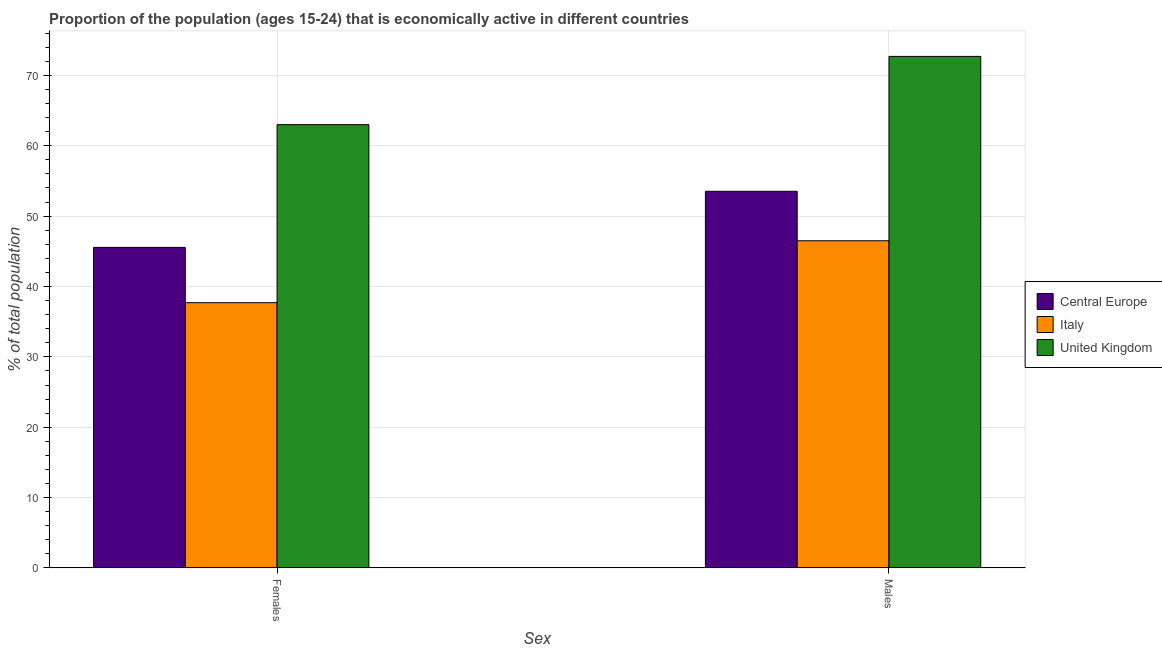How many different coloured bars are there?
Provide a short and direct response. 3. How many bars are there on the 2nd tick from the left?
Offer a terse response. 3. How many bars are there on the 2nd tick from the right?
Keep it short and to the point. 3. What is the label of the 1st group of bars from the left?
Make the answer very short. Females. What is the percentage of economically active female population in United Kingdom?
Ensure brevity in your answer.  63. Across all countries, what is the maximum percentage of economically active male population?
Make the answer very short. 72.7. Across all countries, what is the minimum percentage of economically active female population?
Offer a terse response. 37.7. What is the total percentage of economically active male population in the graph?
Ensure brevity in your answer.  172.73. What is the difference between the percentage of economically active female population in Italy and that in Central Europe?
Keep it short and to the point. -7.86. What is the difference between the percentage of economically active male population in Central Europe and the percentage of economically active female population in Italy?
Your answer should be compact. 15.83. What is the average percentage of economically active male population per country?
Offer a very short reply. 57.58. What is the difference between the percentage of economically active female population and percentage of economically active male population in United Kingdom?
Make the answer very short. -9.7. In how many countries, is the percentage of economically active male population greater than 74 %?
Your answer should be compact. 0. What is the ratio of the percentage of economically active female population in Italy to that in United Kingdom?
Make the answer very short. 0.6. Is the percentage of economically active female population in United Kingdom less than that in Italy?
Offer a very short reply. No. In how many countries, is the percentage of economically active female population greater than the average percentage of economically active female population taken over all countries?
Your response must be concise. 1. What does the 1st bar from the left in Males represents?
Your answer should be very brief. Central Europe. What does the 3rd bar from the right in Males represents?
Provide a succinct answer. Central Europe. How many countries are there in the graph?
Offer a very short reply. 3. What is the difference between two consecutive major ticks on the Y-axis?
Give a very brief answer. 10. Are the values on the major ticks of Y-axis written in scientific E-notation?
Give a very brief answer. No. Does the graph contain grids?
Ensure brevity in your answer.  Yes. Where does the legend appear in the graph?
Offer a very short reply. Center right. How many legend labels are there?
Your answer should be compact. 3. How are the legend labels stacked?
Your answer should be compact. Vertical. What is the title of the graph?
Your answer should be compact. Proportion of the population (ages 15-24) that is economically active in different countries. Does "Korea (Democratic)" appear as one of the legend labels in the graph?
Provide a succinct answer. No. What is the label or title of the X-axis?
Provide a succinct answer. Sex. What is the label or title of the Y-axis?
Provide a succinct answer. % of total population. What is the % of total population in Central Europe in Females?
Ensure brevity in your answer.  45.56. What is the % of total population of Italy in Females?
Your answer should be compact. 37.7. What is the % of total population in Central Europe in Males?
Your response must be concise. 53.53. What is the % of total population of Italy in Males?
Ensure brevity in your answer.  46.5. What is the % of total population of United Kingdom in Males?
Give a very brief answer. 72.7. Across all Sex, what is the maximum % of total population in Central Europe?
Provide a succinct answer. 53.53. Across all Sex, what is the maximum % of total population in Italy?
Your answer should be compact. 46.5. Across all Sex, what is the maximum % of total population of United Kingdom?
Offer a very short reply. 72.7. Across all Sex, what is the minimum % of total population of Central Europe?
Give a very brief answer. 45.56. Across all Sex, what is the minimum % of total population in Italy?
Offer a very short reply. 37.7. What is the total % of total population in Central Europe in the graph?
Your answer should be compact. 99.09. What is the total % of total population of Italy in the graph?
Offer a very short reply. 84.2. What is the total % of total population in United Kingdom in the graph?
Your answer should be compact. 135.7. What is the difference between the % of total population of Central Europe in Females and that in Males?
Offer a terse response. -7.97. What is the difference between the % of total population in Italy in Females and that in Males?
Ensure brevity in your answer.  -8.8. What is the difference between the % of total population in United Kingdom in Females and that in Males?
Your answer should be very brief. -9.7. What is the difference between the % of total population in Central Europe in Females and the % of total population in Italy in Males?
Offer a terse response. -0.94. What is the difference between the % of total population of Central Europe in Females and the % of total population of United Kingdom in Males?
Offer a terse response. -27.14. What is the difference between the % of total population in Italy in Females and the % of total population in United Kingdom in Males?
Offer a terse response. -35. What is the average % of total population in Central Europe per Sex?
Your answer should be compact. 49.54. What is the average % of total population of Italy per Sex?
Ensure brevity in your answer.  42.1. What is the average % of total population in United Kingdom per Sex?
Your response must be concise. 67.85. What is the difference between the % of total population of Central Europe and % of total population of Italy in Females?
Make the answer very short. 7.86. What is the difference between the % of total population in Central Europe and % of total population in United Kingdom in Females?
Your answer should be very brief. -17.44. What is the difference between the % of total population of Italy and % of total population of United Kingdom in Females?
Offer a very short reply. -25.3. What is the difference between the % of total population of Central Europe and % of total population of Italy in Males?
Ensure brevity in your answer.  7.03. What is the difference between the % of total population in Central Europe and % of total population in United Kingdom in Males?
Your answer should be very brief. -19.17. What is the difference between the % of total population in Italy and % of total population in United Kingdom in Males?
Make the answer very short. -26.2. What is the ratio of the % of total population of Central Europe in Females to that in Males?
Provide a succinct answer. 0.85. What is the ratio of the % of total population of Italy in Females to that in Males?
Your response must be concise. 0.81. What is the ratio of the % of total population of United Kingdom in Females to that in Males?
Your response must be concise. 0.87. What is the difference between the highest and the second highest % of total population of Central Europe?
Provide a short and direct response. 7.97. What is the difference between the highest and the second highest % of total population in Italy?
Provide a short and direct response. 8.8. What is the difference between the highest and the lowest % of total population in Central Europe?
Make the answer very short. 7.97. What is the difference between the highest and the lowest % of total population of Italy?
Make the answer very short. 8.8. 